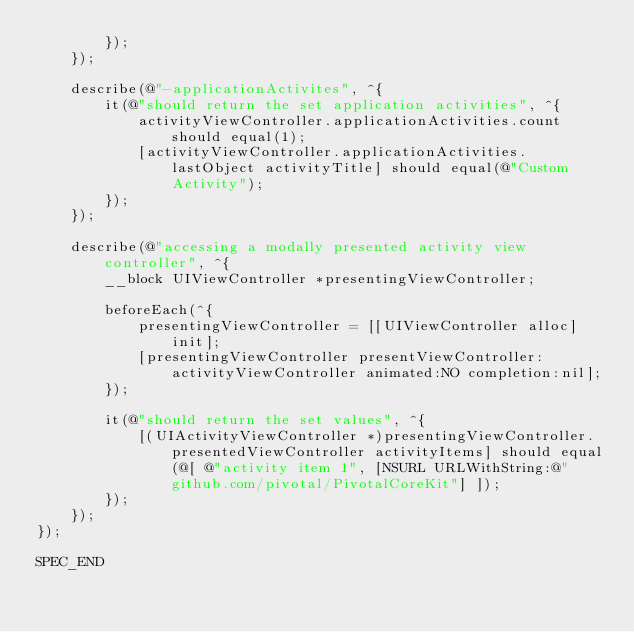<code> <loc_0><loc_0><loc_500><loc_500><_ObjectiveC_>        });
    });

    describe(@"-applicationActivites", ^{
        it(@"should return the set application activities", ^{
            activityViewController.applicationActivities.count should equal(1);
            [activityViewController.applicationActivities.lastObject activityTitle] should equal(@"Custom Activity");
        });
    });

    describe(@"accessing a modally presented activity view controller", ^{
        __block UIViewController *presentingViewController;

        beforeEach(^{
            presentingViewController = [[UIViewController alloc] init];
            [presentingViewController presentViewController:activityViewController animated:NO completion:nil];
        });

        it(@"should return the set values", ^{
            [(UIActivityViewController *)presentingViewController.presentedViewController activityItems] should equal(@[ @"activity item 1", [NSURL URLWithString:@"github.com/pivotal/PivotalCoreKit"] ]);
        });
    });
});

SPEC_END
</code> 